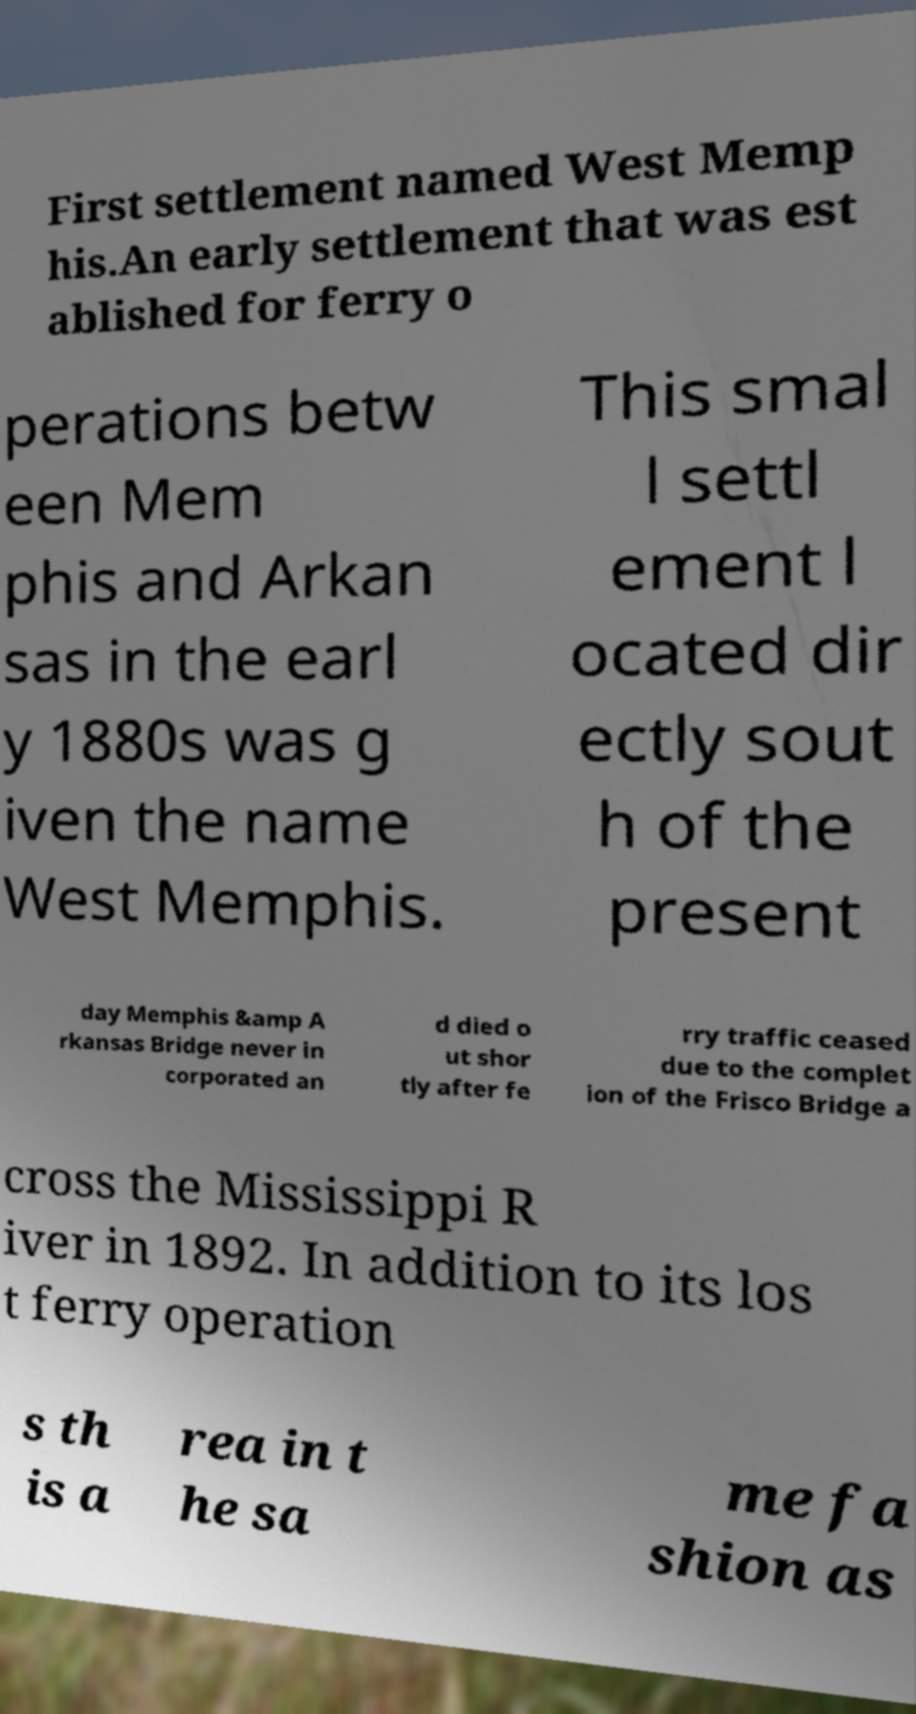I need the written content from this picture converted into text. Can you do that? First settlement named West Memp his.An early settlement that was est ablished for ferry o perations betw een Mem phis and Arkan sas in the earl y 1880s was g iven the name West Memphis. This smal l settl ement l ocated dir ectly sout h of the present day Memphis &amp A rkansas Bridge never in corporated an d died o ut shor tly after fe rry traffic ceased due to the complet ion of the Frisco Bridge a cross the Mississippi R iver in 1892. In addition to its los t ferry operation s th is a rea in t he sa me fa shion as 